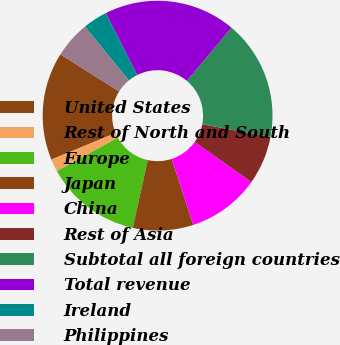<chart> <loc_0><loc_0><loc_500><loc_500><pie_chart><fcel>United States<fcel>Rest of North and South<fcel>Europe<fcel>Japan<fcel>China<fcel>Rest of Asia<fcel>Subtotal all foreign countries<fcel>Total revenue<fcel>Ireland<fcel>Philippines<nl><fcel>15.2%<fcel>1.78%<fcel>13.52%<fcel>8.49%<fcel>10.17%<fcel>6.81%<fcel>16.88%<fcel>18.55%<fcel>3.46%<fcel>5.14%<nl></chart> 